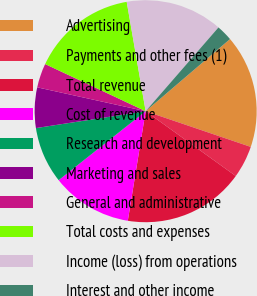Convert chart. <chart><loc_0><loc_0><loc_500><loc_500><pie_chart><fcel>Advertising<fcel>Payments and other fees (1)<fcel>Total revenue<fcel>Cost of revenue<fcel>Research and development<fcel>Marketing and sales<fcel>General and administrative<fcel>Total costs and expenses<fcel>Income (loss) from operations<fcel>Interest and other income<nl><fcel>16.47%<fcel>4.71%<fcel>17.65%<fcel>11.76%<fcel>8.24%<fcel>5.88%<fcel>3.53%<fcel>15.29%<fcel>14.12%<fcel>2.35%<nl></chart> 